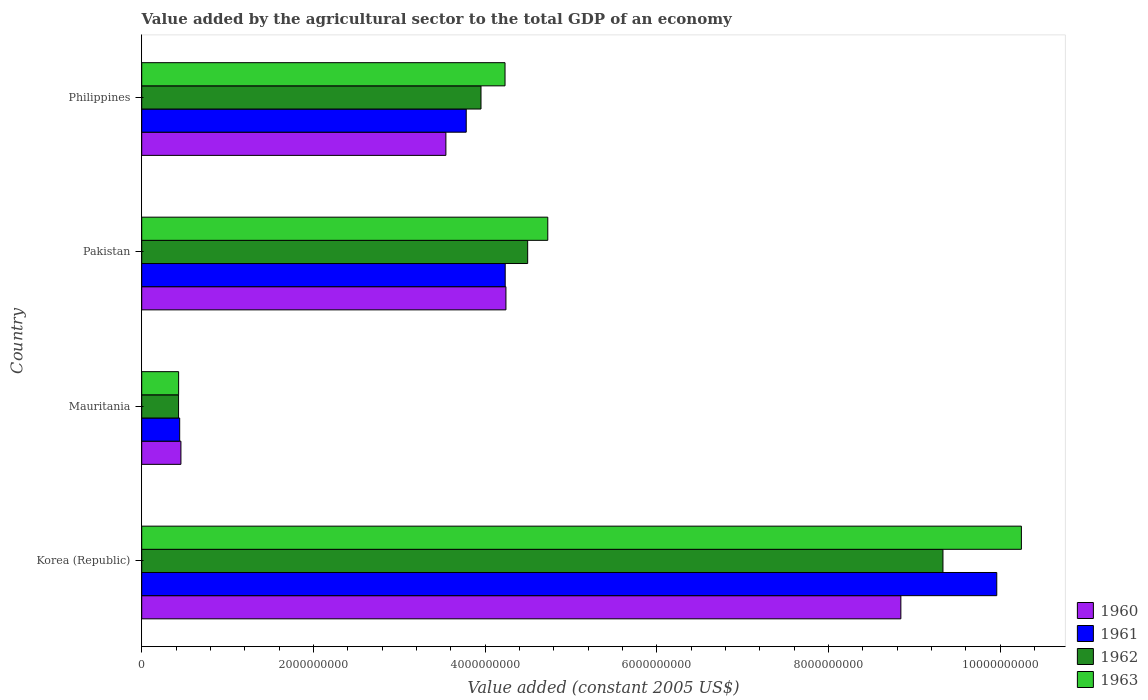How many groups of bars are there?
Ensure brevity in your answer.  4. How many bars are there on the 3rd tick from the top?
Keep it short and to the point. 4. How many bars are there on the 2nd tick from the bottom?
Keep it short and to the point. 4. What is the label of the 3rd group of bars from the top?
Your answer should be very brief. Mauritania. In how many cases, is the number of bars for a given country not equal to the number of legend labels?
Offer a terse response. 0. What is the value added by the agricultural sector in 1961 in Korea (Republic)?
Offer a terse response. 9.96e+09. Across all countries, what is the maximum value added by the agricultural sector in 1963?
Your answer should be compact. 1.02e+1. Across all countries, what is the minimum value added by the agricultural sector in 1961?
Your answer should be compact. 4.42e+08. In which country was the value added by the agricultural sector in 1960 minimum?
Give a very brief answer. Mauritania. What is the total value added by the agricultural sector in 1963 in the graph?
Ensure brevity in your answer.  1.96e+1. What is the difference between the value added by the agricultural sector in 1963 in Korea (Republic) and that in Mauritania?
Offer a very short reply. 9.82e+09. What is the difference between the value added by the agricultural sector in 1963 in Philippines and the value added by the agricultural sector in 1961 in Pakistan?
Give a very brief answer. -2.10e+06. What is the average value added by the agricultural sector in 1963 per country?
Give a very brief answer. 4.91e+09. What is the difference between the value added by the agricultural sector in 1962 and value added by the agricultural sector in 1963 in Korea (Republic)?
Your answer should be very brief. -9.14e+08. In how many countries, is the value added by the agricultural sector in 1960 greater than 6000000000 US$?
Your answer should be very brief. 1. What is the ratio of the value added by the agricultural sector in 1963 in Korea (Republic) to that in Mauritania?
Ensure brevity in your answer.  23.84. Is the difference between the value added by the agricultural sector in 1962 in Mauritania and Pakistan greater than the difference between the value added by the agricultural sector in 1963 in Mauritania and Pakistan?
Your response must be concise. Yes. What is the difference between the highest and the second highest value added by the agricultural sector in 1960?
Your response must be concise. 4.60e+09. What is the difference between the highest and the lowest value added by the agricultural sector in 1963?
Ensure brevity in your answer.  9.82e+09. In how many countries, is the value added by the agricultural sector in 1962 greater than the average value added by the agricultural sector in 1962 taken over all countries?
Give a very brief answer. 1. What does the 3rd bar from the top in Philippines represents?
Ensure brevity in your answer.  1961. What does the 1st bar from the bottom in Philippines represents?
Give a very brief answer. 1960. How many bars are there?
Offer a very short reply. 16. How many countries are there in the graph?
Ensure brevity in your answer.  4. Are the values on the major ticks of X-axis written in scientific E-notation?
Ensure brevity in your answer.  No. Does the graph contain any zero values?
Make the answer very short. No. Does the graph contain grids?
Your answer should be very brief. No. Where does the legend appear in the graph?
Ensure brevity in your answer.  Bottom right. What is the title of the graph?
Keep it short and to the point. Value added by the agricultural sector to the total GDP of an economy. What is the label or title of the X-axis?
Provide a succinct answer. Value added (constant 2005 US$). What is the label or title of the Y-axis?
Your answer should be compact. Country. What is the Value added (constant 2005 US$) of 1960 in Korea (Republic)?
Give a very brief answer. 8.84e+09. What is the Value added (constant 2005 US$) in 1961 in Korea (Republic)?
Your response must be concise. 9.96e+09. What is the Value added (constant 2005 US$) of 1962 in Korea (Republic)?
Provide a short and direct response. 9.33e+09. What is the Value added (constant 2005 US$) of 1963 in Korea (Republic)?
Provide a short and direct response. 1.02e+1. What is the Value added (constant 2005 US$) in 1960 in Mauritania?
Your answer should be very brief. 4.57e+08. What is the Value added (constant 2005 US$) of 1961 in Mauritania?
Keep it short and to the point. 4.42e+08. What is the Value added (constant 2005 US$) in 1962 in Mauritania?
Ensure brevity in your answer.  4.29e+08. What is the Value added (constant 2005 US$) of 1963 in Mauritania?
Offer a terse response. 4.30e+08. What is the Value added (constant 2005 US$) in 1960 in Pakistan?
Your answer should be very brief. 4.24e+09. What is the Value added (constant 2005 US$) in 1961 in Pakistan?
Your answer should be very brief. 4.23e+09. What is the Value added (constant 2005 US$) of 1962 in Pakistan?
Provide a succinct answer. 4.50e+09. What is the Value added (constant 2005 US$) in 1963 in Pakistan?
Your answer should be very brief. 4.73e+09. What is the Value added (constant 2005 US$) of 1960 in Philippines?
Keep it short and to the point. 3.54e+09. What is the Value added (constant 2005 US$) of 1961 in Philippines?
Ensure brevity in your answer.  3.78e+09. What is the Value added (constant 2005 US$) in 1962 in Philippines?
Your answer should be compact. 3.95e+09. What is the Value added (constant 2005 US$) in 1963 in Philippines?
Make the answer very short. 4.23e+09. Across all countries, what is the maximum Value added (constant 2005 US$) in 1960?
Provide a short and direct response. 8.84e+09. Across all countries, what is the maximum Value added (constant 2005 US$) of 1961?
Make the answer very short. 9.96e+09. Across all countries, what is the maximum Value added (constant 2005 US$) in 1962?
Give a very brief answer. 9.33e+09. Across all countries, what is the maximum Value added (constant 2005 US$) in 1963?
Your answer should be compact. 1.02e+1. Across all countries, what is the minimum Value added (constant 2005 US$) of 1960?
Make the answer very short. 4.57e+08. Across all countries, what is the minimum Value added (constant 2005 US$) of 1961?
Your answer should be very brief. 4.42e+08. Across all countries, what is the minimum Value added (constant 2005 US$) in 1962?
Your answer should be compact. 4.29e+08. Across all countries, what is the minimum Value added (constant 2005 US$) of 1963?
Provide a short and direct response. 4.30e+08. What is the total Value added (constant 2005 US$) of 1960 in the graph?
Provide a succinct answer. 1.71e+1. What is the total Value added (constant 2005 US$) in 1961 in the graph?
Your answer should be very brief. 1.84e+1. What is the total Value added (constant 2005 US$) in 1962 in the graph?
Offer a very short reply. 1.82e+1. What is the total Value added (constant 2005 US$) in 1963 in the graph?
Provide a short and direct response. 1.96e+1. What is the difference between the Value added (constant 2005 US$) of 1960 in Korea (Republic) and that in Mauritania?
Keep it short and to the point. 8.39e+09. What is the difference between the Value added (constant 2005 US$) of 1961 in Korea (Republic) and that in Mauritania?
Your answer should be compact. 9.52e+09. What is the difference between the Value added (constant 2005 US$) in 1962 in Korea (Republic) and that in Mauritania?
Your answer should be compact. 8.91e+09. What is the difference between the Value added (constant 2005 US$) of 1963 in Korea (Republic) and that in Mauritania?
Give a very brief answer. 9.82e+09. What is the difference between the Value added (constant 2005 US$) of 1960 in Korea (Republic) and that in Pakistan?
Keep it short and to the point. 4.60e+09. What is the difference between the Value added (constant 2005 US$) in 1961 in Korea (Republic) and that in Pakistan?
Keep it short and to the point. 5.73e+09. What is the difference between the Value added (constant 2005 US$) of 1962 in Korea (Republic) and that in Pakistan?
Your response must be concise. 4.84e+09. What is the difference between the Value added (constant 2005 US$) in 1963 in Korea (Republic) and that in Pakistan?
Your answer should be compact. 5.52e+09. What is the difference between the Value added (constant 2005 US$) in 1960 in Korea (Republic) and that in Philippines?
Your answer should be compact. 5.30e+09. What is the difference between the Value added (constant 2005 US$) of 1961 in Korea (Republic) and that in Philippines?
Ensure brevity in your answer.  6.18e+09. What is the difference between the Value added (constant 2005 US$) of 1962 in Korea (Republic) and that in Philippines?
Offer a very short reply. 5.38e+09. What is the difference between the Value added (constant 2005 US$) in 1963 in Korea (Republic) and that in Philippines?
Your answer should be compact. 6.02e+09. What is the difference between the Value added (constant 2005 US$) in 1960 in Mauritania and that in Pakistan?
Ensure brevity in your answer.  -3.79e+09. What is the difference between the Value added (constant 2005 US$) in 1961 in Mauritania and that in Pakistan?
Offer a terse response. -3.79e+09. What is the difference between the Value added (constant 2005 US$) in 1962 in Mauritania and that in Pakistan?
Provide a succinct answer. -4.07e+09. What is the difference between the Value added (constant 2005 US$) in 1963 in Mauritania and that in Pakistan?
Your answer should be very brief. -4.30e+09. What is the difference between the Value added (constant 2005 US$) of 1960 in Mauritania and that in Philippines?
Keep it short and to the point. -3.09e+09. What is the difference between the Value added (constant 2005 US$) of 1961 in Mauritania and that in Philippines?
Your answer should be compact. -3.34e+09. What is the difference between the Value added (constant 2005 US$) in 1962 in Mauritania and that in Philippines?
Offer a terse response. -3.52e+09. What is the difference between the Value added (constant 2005 US$) in 1963 in Mauritania and that in Philippines?
Give a very brief answer. -3.80e+09. What is the difference between the Value added (constant 2005 US$) in 1960 in Pakistan and that in Philippines?
Offer a terse response. 7.00e+08. What is the difference between the Value added (constant 2005 US$) of 1961 in Pakistan and that in Philippines?
Offer a very short reply. 4.54e+08. What is the difference between the Value added (constant 2005 US$) in 1962 in Pakistan and that in Philippines?
Offer a terse response. 5.44e+08. What is the difference between the Value added (constant 2005 US$) of 1963 in Pakistan and that in Philippines?
Provide a short and direct response. 4.98e+08. What is the difference between the Value added (constant 2005 US$) of 1960 in Korea (Republic) and the Value added (constant 2005 US$) of 1961 in Mauritania?
Offer a terse response. 8.40e+09. What is the difference between the Value added (constant 2005 US$) in 1960 in Korea (Republic) and the Value added (constant 2005 US$) in 1962 in Mauritania?
Keep it short and to the point. 8.41e+09. What is the difference between the Value added (constant 2005 US$) of 1960 in Korea (Republic) and the Value added (constant 2005 US$) of 1963 in Mauritania?
Offer a terse response. 8.41e+09. What is the difference between the Value added (constant 2005 US$) of 1961 in Korea (Republic) and the Value added (constant 2005 US$) of 1962 in Mauritania?
Keep it short and to the point. 9.53e+09. What is the difference between the Value added (constant 2005 US$) in 1961 in Korea (Republic) and the Value added (constant 2005 US$) in 1963 in Mauritania?
Give a very brief answer. 9.53e+09. What is the difference between the Value added (constant 2005 US$) of 1962 in Korea (Republic) and the Value added (constant 2005 US$) of 1963 in Mauritania?
Offer a terse response. 8.90e+09. What is the difference between the Value added (constant 2005 US$) in 1960 in Korea (Republic) and the Value added (constant 2005 US$) in 1961 in Pakistan?
Your answer should be compact. 4.61e+09. What is the difference between the Value added (constant 2005 US$) of 1960 in Korea (Republic) and the Value added (constant 2005 US$) of 1962 in Pakistan?
Offer a terse response. 4.35e+09. What is the difference between the Value added (constant 2005 US$) of 1960 in Korea (Republic) and the Value added (constant 2005 US$) of 1963 in Pakistan?
Your response must be concise. 4.11e+09. What is the difference between the Value added (constant 2005 US$) of 1961 in Korea (Republic) and the Value added (constant 2005 US$) of 1962 in Pakistan?
Provide a succinct answer. 5.46e+09. What is the difference between the Value added (constant 2005 US$) of 1961 in Korea (Republic) and the Value added (constant 2005 US$) of 1963 in Pakistan?
Make the answer very short. 5.23e+09. What is the difference between the Value added (constant 2005 US$) of 1962 in Korea (Republic) and the Value added (constant 2005 US$) of 1963 in Pakistan?
Offer a terse response. 4.60e+09. What is the difference between the Value added (constant 2005 US$) in 1960 in Korea (Republic) and the Value added (constant 2005 US$) in 1961 in Philippines?
Your response must be concise. 5.06e+09. What is the difference between the Value added (constant 2005 US$) of 1960 in Korea (Republic) and the Value added (constant 2005 US$) of 1962 in Philippines?
Offer a terse response. 4.89e+09. What is the difference between the Value added (constant 2005 US$) in 1960 in Korea (Republic) and the Value added (constant 2005 US$) in 1963 in Philippines?
Keep it short and to the point. 4.61e+09. What is the difference between the Value added (constant 2005 US$) of 1961 in Korea (Republic) and the Value added (constant 2005 US$) of 1962 in Philippines?
Ensure brevity in your answer.  6.01e+09. What is the difference between the Value added (constant 2005 US$) in 1961 in Korea (Republic) and the Value added (constant 2005 US$) in 1963 in Philippines?
Offer a terse response. 5.73e+09. What is the difference between the Value added (constant 2005 US$) in 1962 in Korea (Republic) and the Value added (constant 2005 US$) in 1963 in Philippines?
Offer a very short reply. 5.10e+09. What is the difference between the Value added (constant 2005 US$) of 1960 in Mauritania and the Value added (constant 2005 US$) of 1961 in Pakistan?
Your answer should be compact. -3.78e+09. What is the difference between the Value added (constant 2005 US$) of 1960 in Mauritania and the Value added (constant 2005 US$) of 1962 in Pakistan?
Offer a very short reply. -4.04e+09. What is the difference between the Value added (constant 2005 US$) of 1960 in Mauritania and the Value added (constant 2005 US$) of 1963 in Pakistan?
Provide a succinct answer. -4.27e+09. What is the difference between the Value added (constant 2005 US$) in 1961 in Mauritania and the Value added (constant 2005 US$) in 1962 in Pakistan?
Offer a terse response. -4.05e+09. What is the difference between the Value added (constant 2005 US$) in 1961 in Mauritania and the Value added (constant 2005 US$) in 1963 in Pakistan?
Keep it short and to the point. -4.29e+09. What is the difference between the Value added (constant 2005 US$) in 1962 in Mauritania and the Value added (constant 2005 US$) in 1963 in Pakistan?
Provide a succinct answer. -4.30e+09. What is the difference between the Value added (constant 2005 US$) of 1960 in Mauritania and the Value added (constant 2005 US$) of 1961 in Philippines?
Keep it short and to the point. -3.32e+09. What is the difference between the Value added (constant 2005 US$) of 1960 in Mauritania and the Value added (constant 2005 US$) of 1962 in Philippines?
Offer a terse response. -3.50e+09. What is the difference between the Value added (constant 2005 US$) of 1960 in Mauritania and the Value added (constant 2005 US$) of 1963 in Philippines?
Keep it short and to the point. -3.78e+09. What is the difference between the Value added (constant 2005 US$) in 1961 in Mauritania and the Value added (constant 2005 US$) in 1962 in Philippines?
Provide a short and direct response. -3.51e+09. What is the difference between the Value added (constant 2005 US$) in 1961 in Mauritania and the Value added (constant 2005 US$) in 1963 in Philippines?
Your response must be concise. -3.79e+09. What is the difference between the Value added (constant 2005 US$) of 1962 in Mauritania and the Value added (constant 2005 US$) of 1963 in Philippines?
Provide a succinct answer. -3.80e+09. What is the difference between the Value added (constant 2005 US$) in 1960 in Pakistan and the Value added (constant 2005 US$) in 1961 in Philippines?
Your answer should be compact. 4.62e+08. What is the difference between the Value added (constant 2005 US$) in 1960 in Pakistan and the Value added (constant 2005 US$) in 1962 in Philippines?
Make the answer very short. 2.90e+08. What is the difference between the Value added (constant 2005 US$) of 1960 in Pakistan and the Value added (constant 2005 US$) of 1963 in Philippines?
Make the answer very short. 1.07e+07. What is the difference between the Value added (constant 2005 US$) of 1961 in Pakistan and the Value added (constant 2005 US$) of 1962 in Philippines?
Your answer should be compact. 2.82e+08. What is the difference between the Value added (constant 2005 US$) in 1961 in Pakistan and the Value added (constant 2005 US$) in 1963 in Philippines?
Ensure brevity in your answer.  2.10e+06. What is the difference between the Value added (constant 2005 US$) of 1962 in Pakistan and the Value added (constant 2005 US$) of 1963 in Philippines?
Offer a very short reply. 2.64e+08. What is the average Value added (constant 2005 US$) of 1960 per country?
Your answer should be compact. 4.27e+09. What is the average Value added (constant 2005 US$) in 1961 per country?
Make the answer very short. 4.60e+09. What is the average Value added (constant 2005 US$) in 1962 per country?
Offer a terse response. 4.55e+09. What is the average Value added (constant 2005 US$) in 1963 per country?
Your answer should be compact. 4.91e+09. What is the difference between the Value added (constant 2005 US$) in 1960 and Value added (constant 2005 US$) in 1961 in Korea (Republic)?
Ensure brevity in your answer.  -1.12e+09. What is the difference between the Value added (constant 2005 US$) in 1960 and Value added (constant 2005 US$) in 1962 in Korea (Republic)?
Make the answer very short. -4.90e+08. What is the difference between the Value added (constant 2005 US$) of 1960 and Value added (constant 2005 US$) of 1963 in Korea (Republic)?
Your answer should be very brief. -1.40e+09. What is the difference between the Value added (constant 2005 US$) in 1961 and Value added (constant 2005 US$) in 1962 in Korea (Republic)?
Provide a succinct answer. 6.27e+08. What is the difference between the Value added (constant 2005 US$) in 1961 and Value added (constant 2005 US$) in 1963 in Korea (Republic)?
Offer a very short reply. -2.87e+08. What is the difference between the Value added (constant 2005 US$) in 1962 and Value added (constant 2005 US$) in 1963 in Korea (Republic)?
Give a very brief answer. -9.14e+08. What is the difference between the Value added (constant 2005 US$) in 1960 and Value added (constant 2005 US$) in 1961 in Mauritania?
Make the answer very short. 1.44e+07. What is the difference between the Value added (constant 2005 US$) in 1960 and Value added (constant 2005 US$) in 1962 in Mauritania?
Your answer should be very brief. 2.75e+07. What is the difference between the Value added (constant 2005 US$) in 1960 and Value added (constant 2005 US$) in 1963 in Mauritania?
Make the answer very short. 2.68e+07. What is the difference between the Value added (constant 2005 US$) in 1961 and Value added (constant 2005 US$) in 1962 in Mauritania?
Make the answer very short. 1.31e+07. What is the difference between the Value added (constant 2005 US$) in 1961 and Value added (constant 2005 US$) in 1963 in Mauritania?
Keep it short and to the point. 1.24e+07. What is the difference between the Value added (constant 2005 US$) of 1962 and Value added (constant 2005 US$) of 1963 in Mauritania?
Make the answer very short. -7.06e+05. What is the difference between the Value added (constant 2005 US$) in 1960 and Value added (constant 2005 US$) in 1961 in Pakistan?
Give a very brief answer. 8.56e+06. What is the difference between the Value added (constant 2005 US$) in 1960 and Value added (constant 2005 US$) in 1962 in Pakistan?
Offer a terse response. -2.53e+08. What is the difference between the Value added (constant 2005 US$) in 1960 and Value added (constant 2005 US$) in 1963 in Pakistan?
Your response must be concise. -4.87e+08. What is the difference between the Value added (constant 2005 US$) in 1961 and Value added (constant 2005 US$) in 1962 in Pakistan?
Make the answer very short. -2.62e+08. What is the difference between the Value added (constant 2005 US$) of 1961 and Value added (constant 2005 US$) of 1963 in Pakistan?
Your answer should be very brief. -4.96e+08. What is the difference between the Value added (constant 2005 US$) in 1962 and Value added (constant 2005 US$) in 1963 in Pakistan?
Offer a terse response. -2.34e+08. What is the difference between the Value added (constant 2005 US$) of 1960 and Value added (constant 2005 US$) of 1961 in Philippines?
Your answer should be compact. -2.37e+08. What is the difference between the Value added (constant 2005 US$) in 1960 and Value added (constant 2005 US$) in 1962 in Philippines?
Give a very brief answer. -4.09e+08. What is the difference between the Value added (constant 2005 US$) of 1960 and Value added (constant 2005 US$) of 1963 in Philippines?
Offer a terse response. -6.89e+08. What is the difference between the Value added (constant 2005 US$) of 1961 and Value added (constant 2005 US$) of 1962 in Philippines?
Your answer should be compact. -1.72e+08. What is the difference between the Value added (constant 2005 US$) in 1961 and Value added (constant 2005 US$) in 1963 in Philippines?
Give a very brief answer. -4.52e+08. What is the difference between the Value added (constant 2005 US$) in 1962 and Value added (constant 2005 US$) in 1963 in Philippines?
Make the answer very short. -2.80e+08. What is the ratio of the Value added (constant 2005 US$) in 1960 in Korea (Republic) to that in Mauritania?
Your answer should be very brief. 19.37. What is the ratio of the Value added (constant 2005 US$) in 1961 in Korea (Republic) to that in Mauritania?
Offer a very short reply. 22.52. What is the ratio of the Value added (constant 2005 US$) of 1962 in Korea (Republic) to that in Mauritania?
Your response must be concise. 21.75. What is the ratio of the Value added (constant 2005 US$) in 1963 in Korea (Republic) to that in Mauritania?
Your response must be concise. 23.84. What is the ratio of the Value added (constant 2005 US$) in 1960 in Korea (Republic) to that in Pakistan?
Keep it short and to the point. 2.08. What is the ratio of the Value added (constant 2005 US$) of 1961 in Korea (Republic) to that in Pakistan?
Offer a very short reply. 2.35. What is the ratio of the Value added (constant 2005 US$) in 1962 in Korea (Republic) to that in Pakistan?
Offer a very short reply. 2.08. What is the ratio of the Value added (constant 2005 US$) of 1963 in Korea (Republic) to that in Pakistan?
Give a very brief answer. 2.17. What is the ratio of the Value added (constant 2005 US$) of 1960 in Korea (Republic) to that in Philippines?
Keep it short and to the point. 2.5. What is the ratio of the Value added (constant 2005 US$) of 1961 in Korea (Republic) to that in Philippines?
Your response must be concise. 2.63. What is the ratio of the Value added (constant 2005 US$) of 1962 in Korea (Republic) to that in Philippines?
Ensure brevity in your answer.  2.36. What is the ratio of the Value added (constant 2005 US$) of 1963 in Korea (Republic) to that in Philippines?
Provide a short and direct response. 2.42. What is the ratio of the Value added (constant 2005 US$) of 1960 in Mauritania to that in Pakistan?
Provide a short and direct response. 0.11. What is the ratio of the Value added (constant 2005 US$) of 1961 in Mauritania to that in Pakistan?
Provide a succinct answer. 0.1. What is the ratio of the Value added (constant 2005 US$) of 1962 in Mauritania to that in Pakistan?
Offer a terse response. 0.1. What is the ratio of the Value added (constant 2005 US$) of 1963 in Mauritania to that in Pakistan?
Offer a terse response. 0.09. What is the ratio of the Value added (constant 2005 US$) in 1960 in Mauritania to that in Philippines?
Your answer should be very brief. 0.13. What is the ratio of the Value added (constant 2005 US$) in 1961 in Mauritania to that in Philippines?
Ensure brevity in your answer.  0.12. What is the ratio of the Value added (constant 2005 US$) of 1962 in Mauritania to that in Philippines?
Make the answer very short. 0.11. What is the ratio of the Value added (constant 2005 US$) of 1963 in Mauritania to that in Philippines?
Your response must be concise. 0.1. What is the ratio of the Value added (constant 2005 US$) of 1960 in Pakistan to that in Philippines?
Provide a succinct answer. 1.2. What is the ratio of the Value added (constant 2005 US$) of 1961 in Pakistan to that in Philippines?
Keep it short and to the point. 1.12. What is the ratio of the Value added (constant 2005 US$) in 1962 in Pakistan to that in Philippines?
Offer a very short reply. 1.14. What is the ratio of the Value added (constant 2005 US$) of 1963 in Pakistan to that in Philippines?
Your answer should be compact. 1.12. What is the difference between the highest and the second highest Value added (constant 2005 US$) in 1960?
Offer a terse response. 4.60e+09. What is the difference between the highest and the second highest Value added (constant 2005 US$) in 1961?
Provide a short and direct response. 5.73e+09. What is the difference between the highest and the second highest Value added (constant 2005 US$) of 1962?
Ensure brevity in your answer.  4.84e+09. What is the difference between the highest and the second highest Value added (constant 2005 US$) of 1963?
Your answer should be very brief. 5.52e+09. What is the difference between the highest and the lowest Value added (constant 2005 US$) in 1960?
Keep it short and to the point. 8.39e+09. What is the difference between the highest and the lowest Value added (constant 2005 US$) of 1961?
Offer a terse response. 9.52e+09. What is the difference between the highest and the lowest Value added (constant 2005 US$) in 1962?
Make the answer very short. 8.91e+09. What is the difference between the highest and the lowest Value added (constant 2005 US$) in 1963?
Keep it short and to the point. 9.82e+09. 